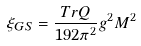Convert formula to latex. <formula><loc_0><loc_0><loc_500><loc_500>\xi _ { G S } = { \frac { T r Q } { 1 9 2 \pi ^ { 2 } } } g ^ { 2 } M ^ { 2 }</formula> 